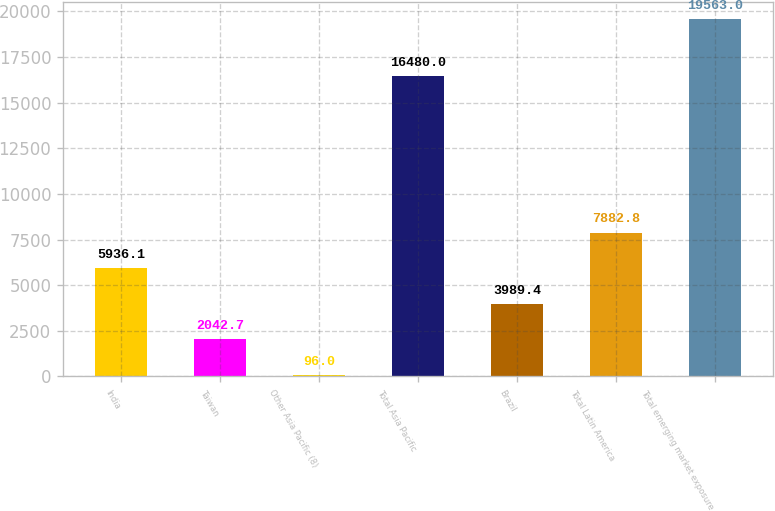Convert chart. <chart><loc_0><loc_0><loc_500><loc_500><bar_chart><fcel>India<fcel>Taiwan<fcel>Other Asia Pacific (8)<fcel>Total Asia Pacific<fcel>Brazil<fcel>Total Latin America<fcel>Total emerging market exposure<nl><fcel>5936.1<fcel>2042.7<fcel>96<fcel>16480<fcel>3989.4<fcel>7882.8<fcel>19563<nl></chart> 